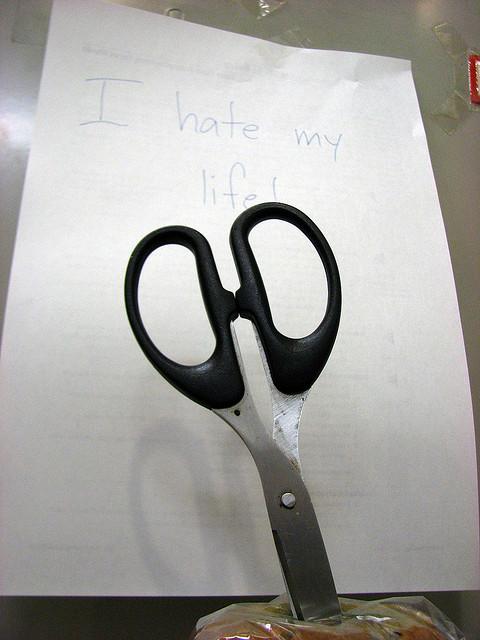What does the photographer hate?
Short answer required. Life. What is shadow of?
Write a very short answer. Scissors. What item is this?
Keep it brief. Scissors. 